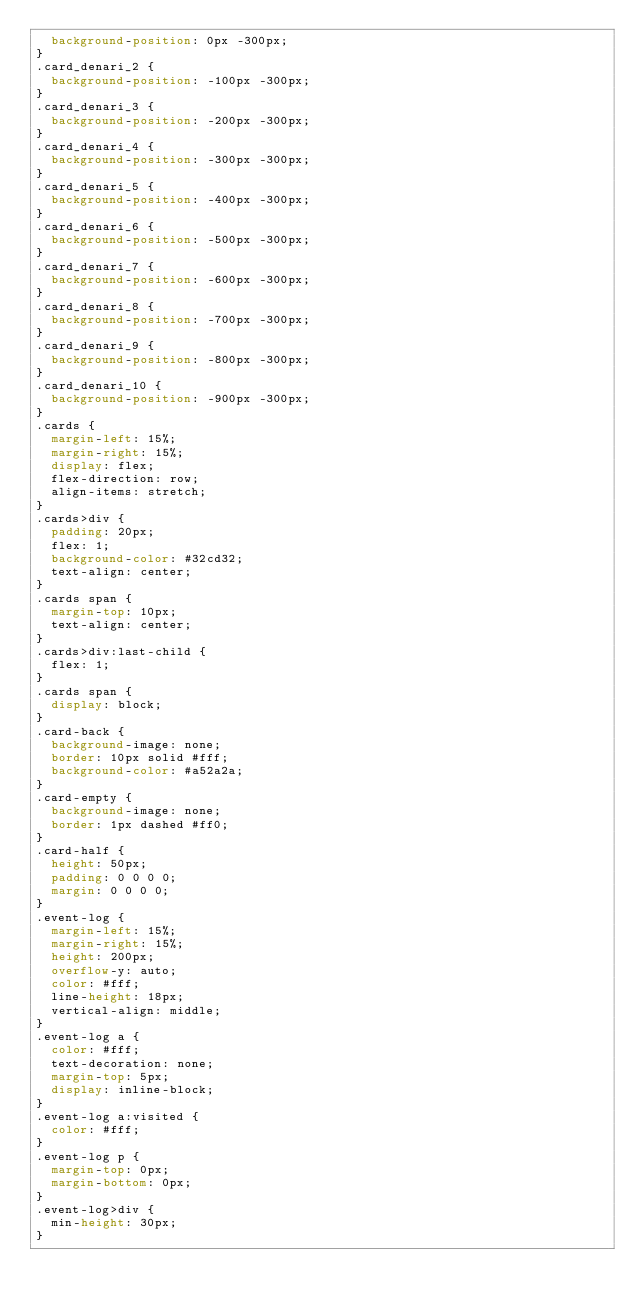Convert code to text. <code><loc_0><loc_0><loc_500><loc_500><_CSS_>  background-position: 0px -300px;
}
.card_denari_2 {
  background-position: -100px -300px;
}
.card_denari_3 {
  background-position: -200px -300px;
}
.card_denari_4 {
  background-position: -300px -300px;
}
.card_denari_5 {
  background-position: -400px -300px;
}
.card_denari_6 {
  background-position: -500px -300px;
}
.card_denari_7 {
  background-position: -600px -300px;
}
.card_denari_8 {
  background-position: -700px -300px;
}
.card_denari_9 {
  background-position: -800px -300px;
}
.card_denari_10 {
  background-position: -900px -300px;
}
.cards {
  margin-left: 15%;
  margin-right: 15%;
  display: flex;
  flex-direction: row;
  align-items: stretch;
}
.cards>div {
  padding: 20px;
  flex: 1;
  background-color: #32cd32;
  text-align: center;
}
.cards span {
  margin-top: 10px;
  text-align: center;
}
.cards>div:last-child {
  flex: 1;
}
.cards span {
  display: block;
}
.card-back {
  background-image: none;
  border: 10px solid #fff;
  background-color: #a52a2a;
}
.card-empty {
  background-image: none;
  border: 1px dashed #ff0;
}
.card-half {
  height: 50px;
  padding: 0 0 0 0;
  margin: 0 0 0 0;
}
.event-log {
  margin-left: 15%;
  margin-right: 15%;
  height: 200px;
  overflow-y: auto;
  color: #fff;
  line-height: 18px;
  vertical-align: middle;
}
.event-log a {
  color: #fff;
  text-decoration: none;
  margin-top: 5px;
  display: inline-block;
}
.event-log a:visited {
  color: #fff;
}
.event-log p {
  margin-top: 0px;
  margin-bottom: 0px;
}
.event-log>div {
  min-height: 30px;
}</code> 